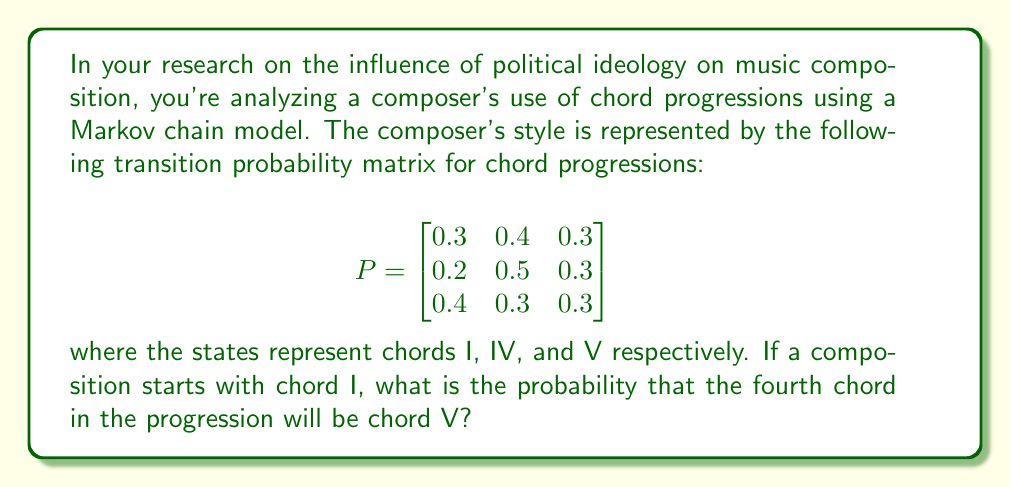Give your solution to this math problem. To solve this problem, we need to use the Chapman-Kolmogorov equations and calculate the 3-step transition probability from state 1 (chord I) to state 3 (chord V). This can be done by raising the transition matrix to the power of 3.

Step 1: Calculate $P^3$
$$P^3 = P \times P \times P$$

We can use matrix multiplication to compute this:

$$P^2 = \begin{bmatrix}
0.29 & 0.41 & 0.30 \\
0.28 & 0.42 & 0.30 \\
0.31 & 0.39 & 0.30
\end{bmatrix}$$

$$P^3 = P \times P^2 = \begin{bmatrix}
0.292 & 0.408 & 0.300 \\
0.288 & 0.412 & 0.300 \\
0.296 & 0.404 & 0.300
\end{bmatrix}$$

Step 2: Interpret the result
The probability we're looking for is the element in the first row (since we start with chord I) and third column (since we want to end with chord V) of $P^3$.

This probability is 0.300 or 30%.
Answer: 0.300 